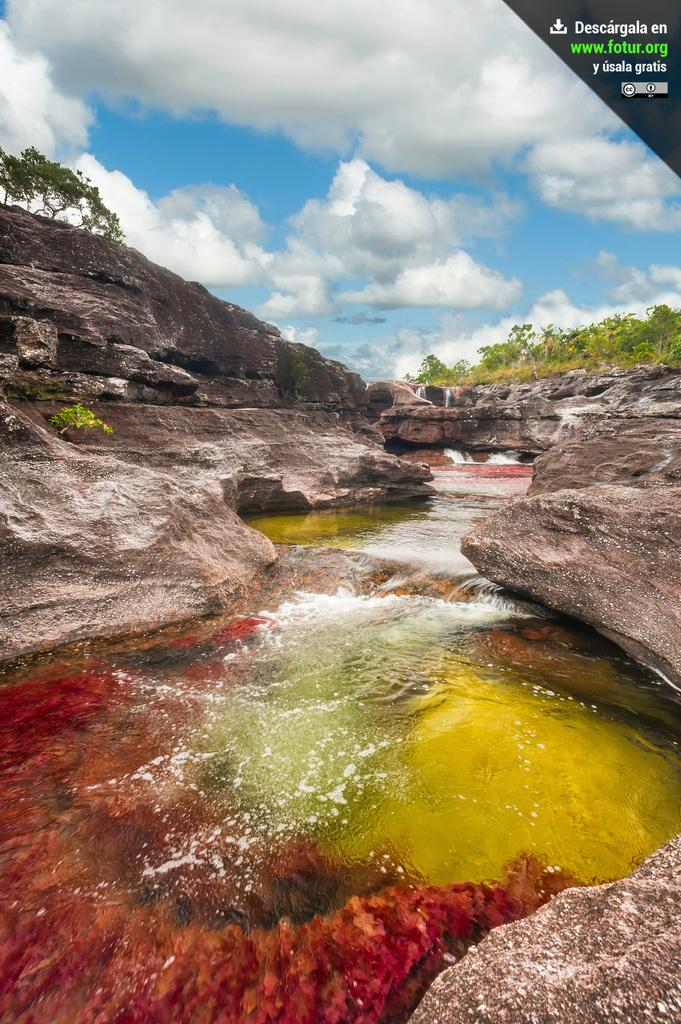What type of natural elements can be seen in the image? Rocks, water, and trees are visible in the image. What is the condition of the sky in the image? The sky is cloudy in the image. Can you describe the water in the image? The water is present in the image, but its specific characteristics are not mentioned in the provided facts. What additional feature can be found at the top right side of the image? There is a watermark at the top right side of the image. How many legs can be seen on the worm in the image? There is no worm present in the image, so it is not possible to determine the number of legs on a worm. 